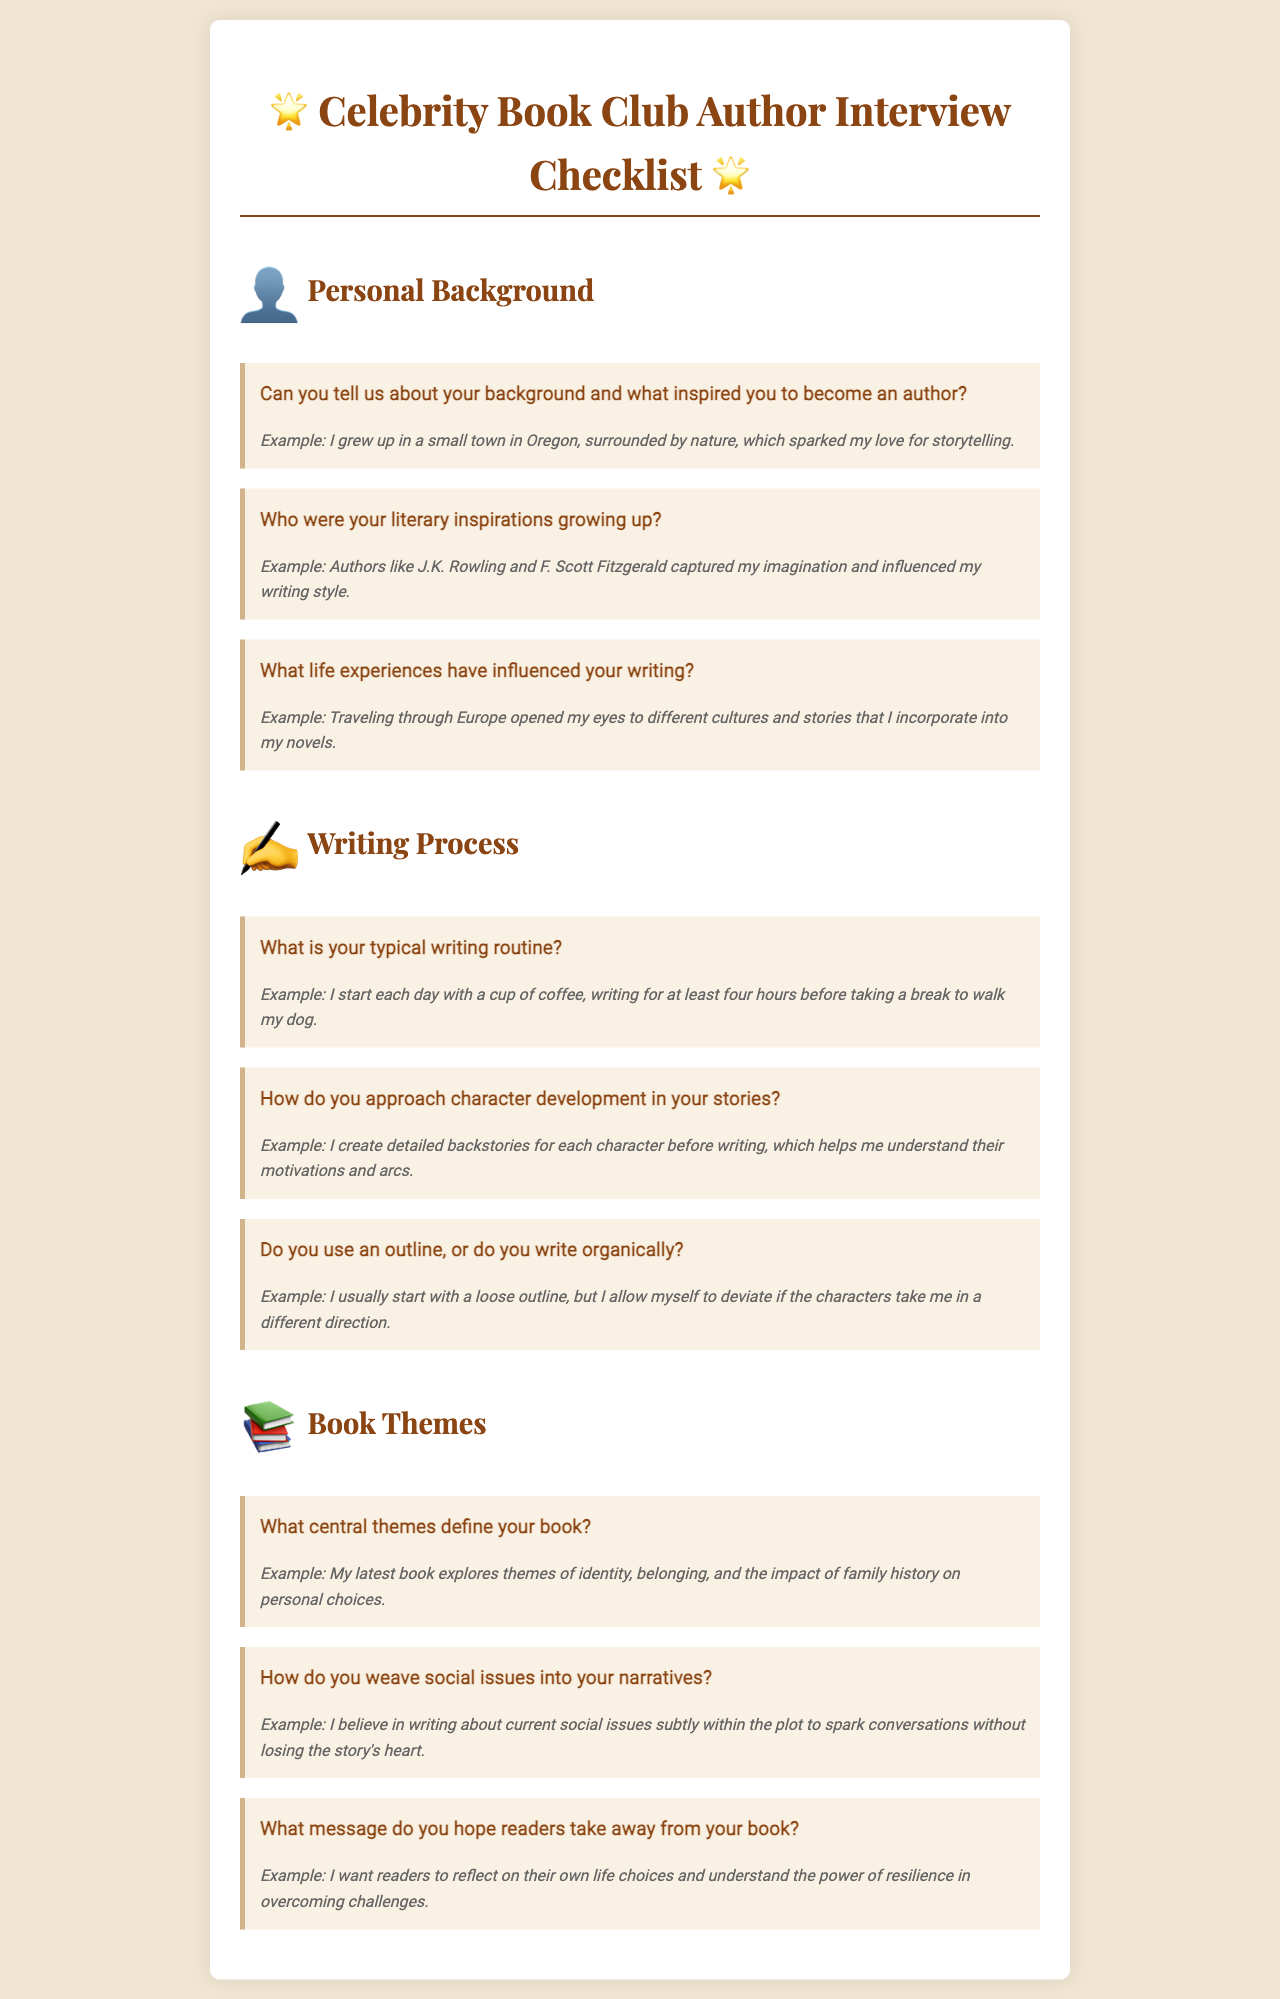What is the title of the document? The title is presented at the top of the rendered document, indicating the document's purpose.
Answer: Celebrity Book Club Author Interview Checklist How many sections are there in the document? The document contains three main sections, each with questions.
Answer: Three What is the theme of the first question in the Personal Background section? The theme relates to the author's inspiration and background that led to becoming an author.
Answer: Background and inspiration What does the author use to aid in character development? This detail describes a specific practice the author employs to create characters.
Answer: Detailed backstories What central theme does the author explore in their latest book? The question asks for specific themes within the author's book.
Answer: Identity, belonging, and family history How does the author integrate social issues into their narratives? This question explores the technique the author uses to address real-world issues in their writing.
Answer: Subtly within the plot What is the author's typical writing routine? The answer refers to the daily practices the author follows when writing.
Answer: A cup of coffee and writing for at least four hours What message does the author hope readers take away? This question addresses the overarching message depicted in the author's work.
Answer: Reflect on life choices and resilience 